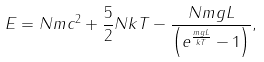Convert formula to latex. <formula><loc_0><loc_0><loc_500><loc_500>E = N m c ^ { 2 } + \frac { 5 } { 2 } N k T - \frac { N m g L } { \left ( e ^ { \frac { m g L } { k T } } - 1 \right ) } ,</formula> 